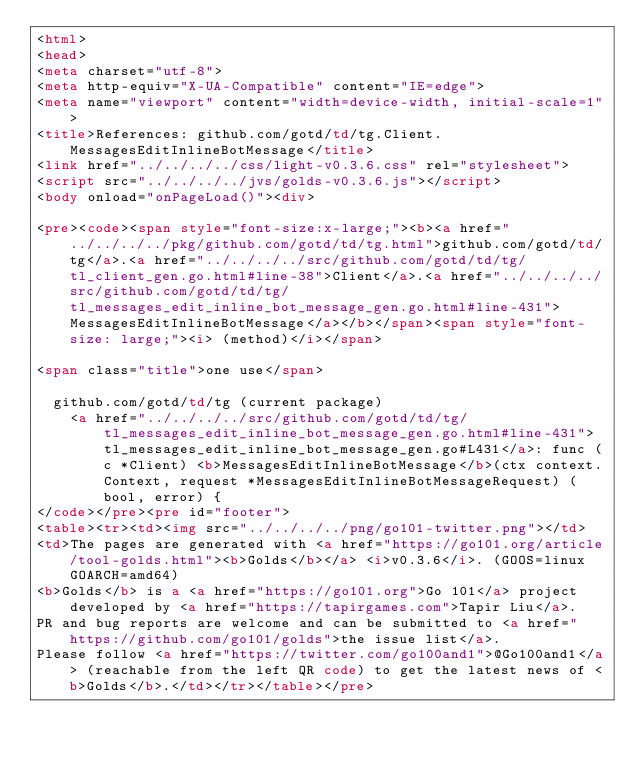<code> <loc_0><loc_0><loc_500><loc_500><_HTML_><html>
<head>
<meta charset="utf-8">
<meta http-equiv="X-UA-Compatible" content="IE=edge">
<meta name="viewport" content="width=device-width, initial-scale=1">
<title>References: github.com/gotd/td/tg.Client.MessagesEditInlineBotMessage</title>
<link href="../../../../css/light-v0.3.6.css" rel="stylesheet">
<script src="../../../../jvs/golds-v0.3.6.js"></script>
<body onload="onPageLoad()"><div>

<pre><code><span style="font-size:x-large;"><b><a href="../../../../pkg/github.com/gotd/td/tg.html">github.com/gotd/td/tg</a>.<a href="../../../../src/github.com/gotd/td/tg/tl_client_gen.go.html#line-38">Client</a>.<a href="../../../../src/github.com/gotd/td/tg/tl_messages_edit_inline_bot_message_gen.go.html#line-431">MessagesEditInlineBotMessage</a></b></span><span style="font-size: large;"><i> (method)</i></span>

<span class="title">one use</span>

	github.com/gotd/td/tg (current package)
		<a href="../../../../src/github.com/gotd/td/tg/tl_messages_edit_inline_bot_message_gen.go.html#line-431">tl_messages_edit_inline_bot_message_gen.go#L431</a>: func (c *Client) <b>MessagesEditInlineBotMessage</b>(ctx context.Context, request *MessagesEditInlineBotMessageRequest) (bool, error) {
</code></pre><pre id="footer">
<table><tr><td><img src="../../../../png/go101-twitter.png"></td>
<td>The pages are generated with <a href="https://go101.org/article/tool-golds.html"><b>Golds</b></a> <i>v0.3.6</i>. (GOOS=linux GOARCH=amd64)
<b>Golds</b> is a <a href="https://go101.org">Go 101</a> project developed by <a href="https://tapirgames.com">Tapir Liu</a>.
PR and bug reports are welcome and can be submitted to <a href="https://github.com/go101/golds">the issue list</a>.
Please follow <a href="https://twitter.com/go100and1">@Go100and1</a> (reachable from the left QR code) to get the latest news of <b>Golds</b>.</td></tr></table></pre></code> 